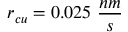Convert formula to latex. <formula><loc_0><loc_0><loc_500><loc_500>r _ { c u } = 0 . 0 2 5 \frac { n m } { s }</formula> 